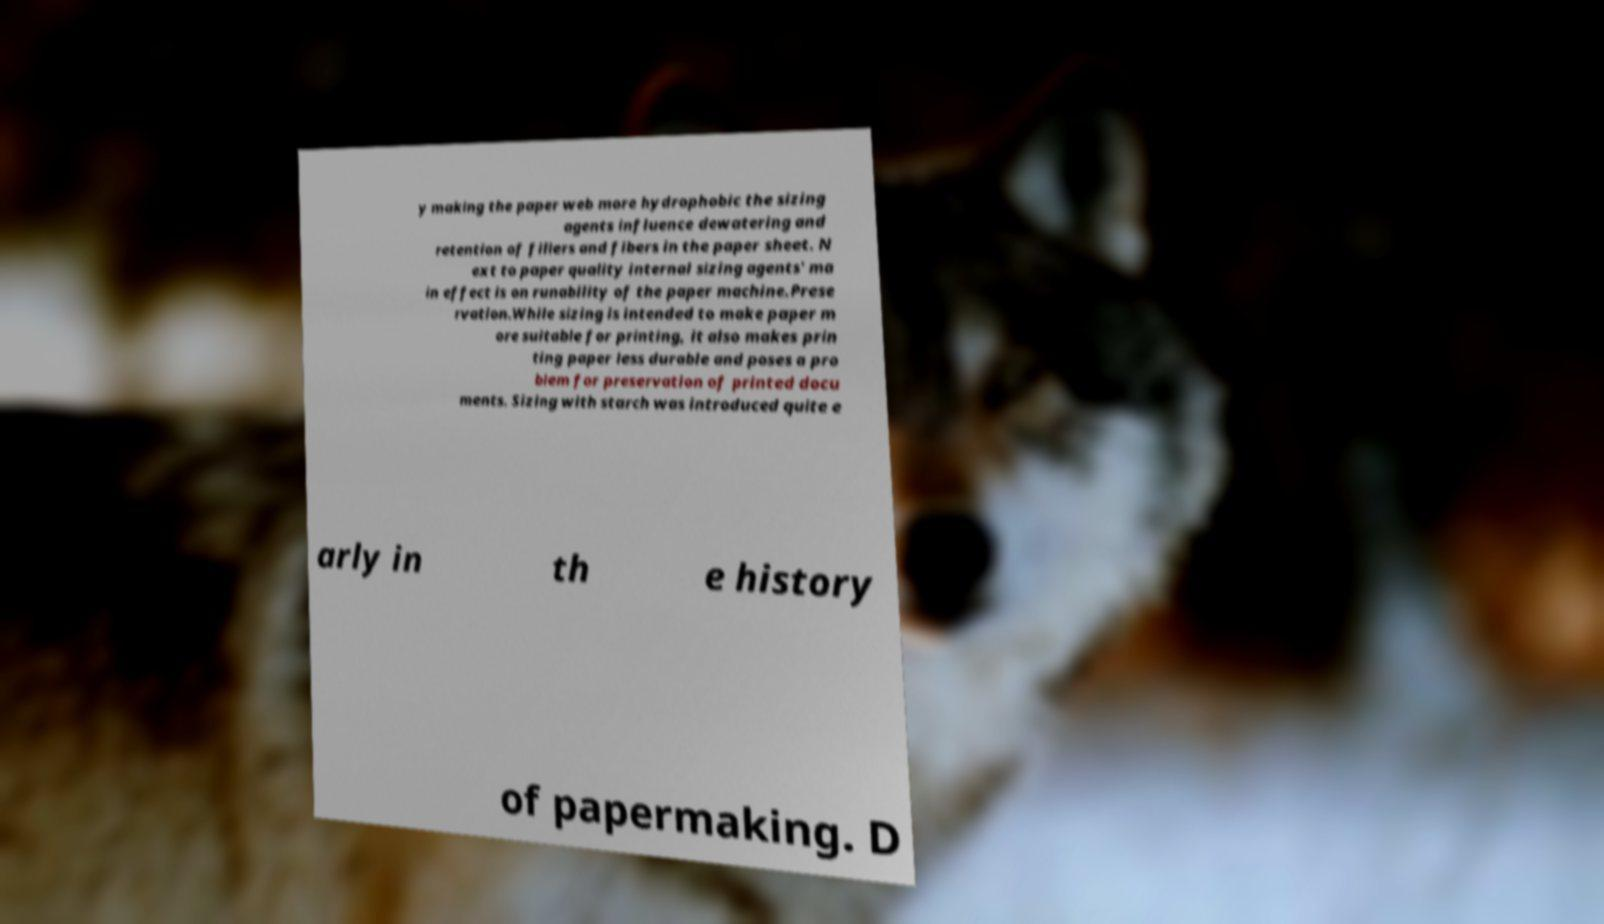There's text embedded in this image that I need extracted. Can you transcribe it verbatim? y making the paper web more hydrophobic the sizing agents influence dewatering and retention of fillers and fibers in the paper sheet. N ext to paper quality internal sizing agents' ma in effect is on runability of the paper machine.Prese rvation.While sizing is intended to make paper m ore suitable for printing, it also makes prin ting paper less durable and poses a pro blem for preservation of printed docu ments. Sizing with starch was introduced quite e arly in th e history of papermaking. D 